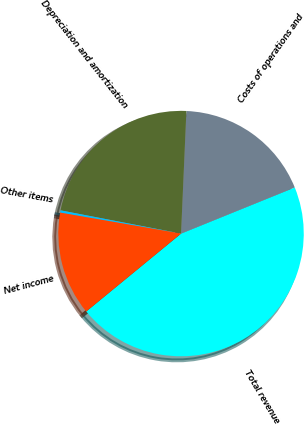<chart> <loc_0><loc_0><loc_500><loc_500><pie_chart><fcel>Total revenue<fcel>Costs of operations and<fcel>Depreciation and amortization<fcel>Other items<fcel>Net income<nl><fcel>45.18%<fcel>18.17%<fcel>22.66%<fcel>0.3%<fcel>13.68%<nl></chart> 